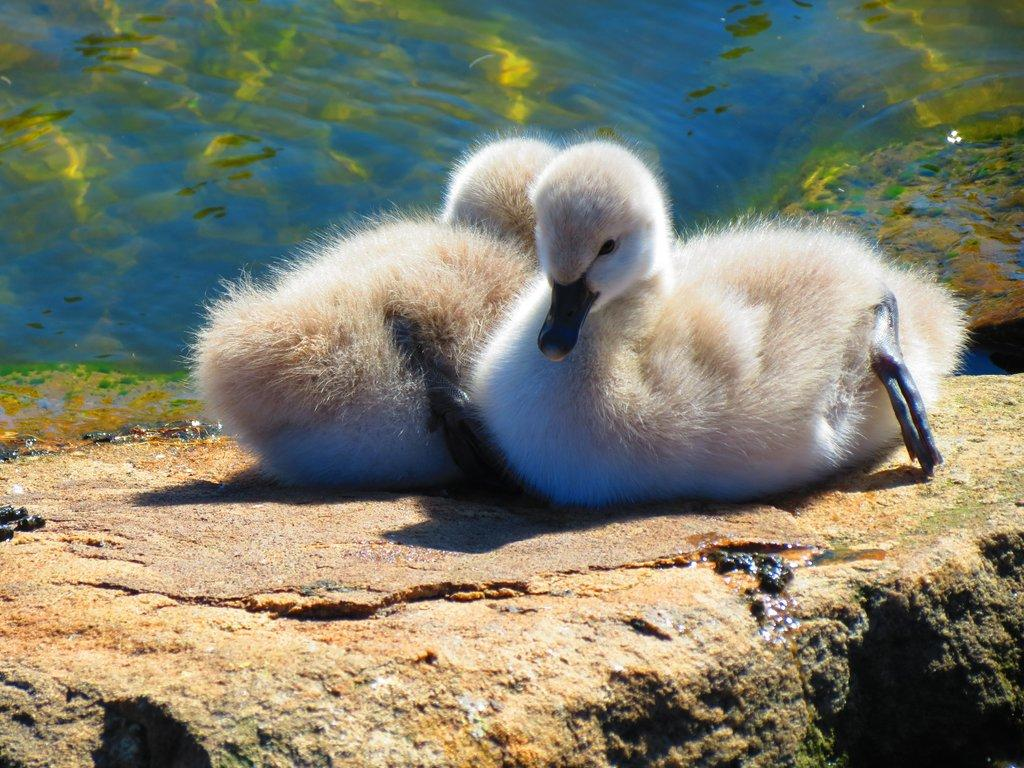What type of animals are in the image? There are two white ducks in the image. Where are the ducks located? The ducks are on a rock surface. How many men are visible in the image? There are no men present in the image; it features two white ducks on a rock surface. What is the value of the dime shown in the image? There is no dime present in the image. 